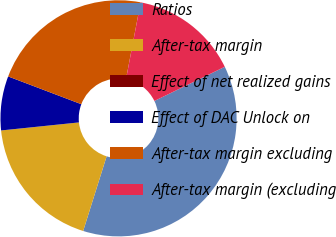Convert chart to OTSL. <chart><loc_0><loc_0><loc_500><loc_500><pie_chart><fcel>Ratios<fcel>After-tax margin<fcel>Effect of net realized gains<fcel>Effect of DAC Unlock on<fcel>After-tax margin excluding<fcel>After-tax margin (excluding<nl><fcel>37.03%<fcel>18.52%<fcel>0.0%<fcel>7.41%<fcel>22.22%<fcel>14.82%<nl></chart> 